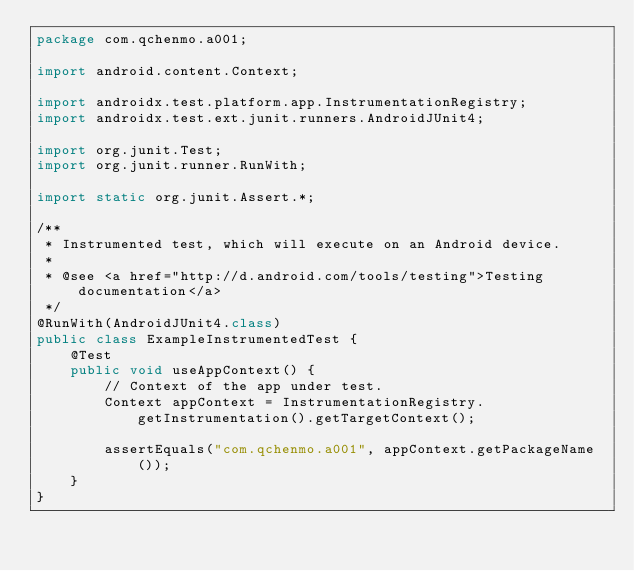<code> <loc_0><loc_0><loc_500><loc_500><_Java_>package com.qchenmo.a001;

import android.content.Context;

import androidx.test.platform.app.InstrumentationRegistry;
import androidx.test.ext.junit.runners.AndroidJUnit4;

import org.junit.Test;
import org.junit.runner.RunWith;

import static org.junit.Assert.*;

/**
 * Instrumented test, which will execute on an Android device.
 *
 * @see <a href="http://d.android.com/tools/testing">Testing documentation</a>
 */
@RunWith(AndroidJUnit4.class)
public class ExampleInstrumentedTest {
    @Test
    public void useAppContext() {
        // Context of the app under test.
        Context appContext = InstrumentationRegistry.getInstrumentation().getTargetContext();

        assertEquals("com.qchenmo.a001", appContext.getPackageName());
    }
}
</code> 